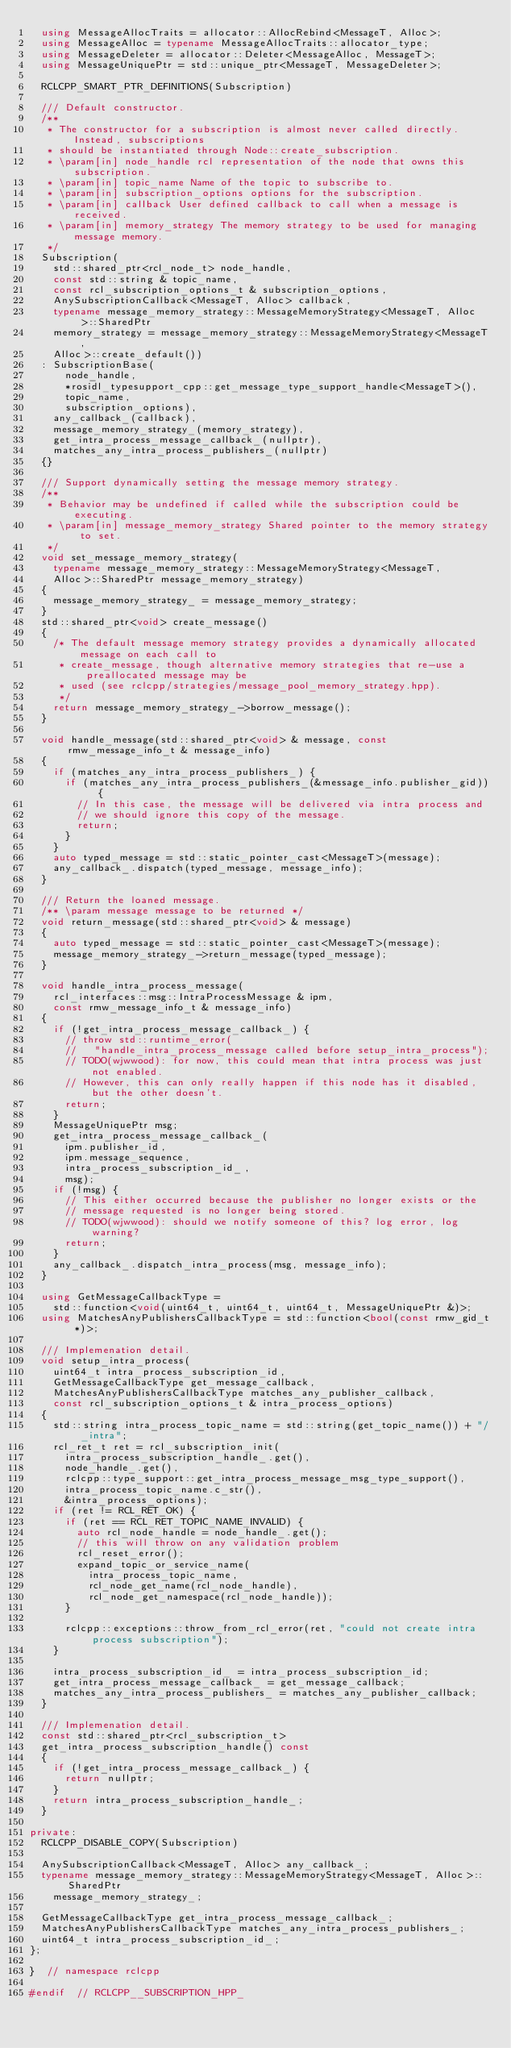<code> <loc_0><loc_0><loc_500><loc_500><_C++_>  using MessageAllocTraits = allocator::AllocRebind<MessageT, Alloc>;
  using MessageAlloc = typename MessageAllocTraits::allocator_type;
  using MessageDeleter = allocator::Deleter<MessageAlloc, MessageT>;
  using MessageUniquePtr = std::unique_ptr<MessageT, MessageDeleter>;

  RCLCPP_SMART_PTR_DEFINITIONS(Subscription)

  /// Default constructor.
  /**
   * The constructor for a subscription is almost never called directly. Instead, subscriptions
   * should be instantiated through Node::create_subscription.
   * \param[in] node_handle rcl representation of the node that owns this subscription.
   * \param[in] topic_name Name of the topic to subscribe to.
   * \param[in] subscription_options options for the subscription.
   * \param[in] callback User defined callback to call when a message is received.
   * \param[in] memory_strategy The memory strategy to be used for managing message memory.
   */
  Subscription(
    std::shared_ptr<rcl_node_t> node_handle,
    const std::string & topic_name,
    const rcl_subscription_options_t & subscription_options,
    AnySubscriptionCallback<MessageT, Alloc> callback,
    typename message_memory_strategy::MessageMemoryStrategy<MessageT, Alloc>::SharedPtr
    memory_strategy = message_memory_strategy::MessageMemoryStrategy<MessageT,
    Alloc>::create_default())
  : SubscriptionBase(
      node_handle,
      *rosidl_typesupport_cpp::get_message_type_support_handle<MessageT>(),
      topic_name,
      subscription_options),
    any_callback_(callback),
    message_memory_strategy_(memory_strategy),
    get_intra_process_message_callback_(nullptr),
    matches_any_intra_process_publishers_(nullptr)
  {}

  /// Support dynamically setting the message memory strategy.
  /**
   * Behavior may be undefined if called while the subscription could be executing.
   * \param[in] message_memory_strategy Shared pointer to the memory strategy to set.
   */
  void set_message_memory_strategy(
    typename message_memory_strategy::MessageMemoryStrategy<MessageT,
    Alloc>::SharedPtr message_memory_strategy)
  {
    message_memory_strategy_ = message_memory_strategy;
  }
  std::shared_ptr<void> create_message()
  {
    /* The default message memory strategy provides a dynamically allocated message on each call to
     * create_message, though alternative memory strategies that re-use a preallocated message may be
     * used (see rclcpp/strategies/message_pool_memory_strategy.hpp).
     */
    return message_memory_strategy_->borrow_message();
  }

  void handle_message(std::shared_ptr<void> & message, const rmw_message_info_t & message_info)
  {
    if (matches_any_intra_process_publishers_) {
      if (matches_any_intra_process_publishers_(&message_info.publisher_gid)) {
        // In this case, the message will be delivered via intra process and
        // we should ignore this copy of the message.
        return;
      }
    }
    auto typed_message = std::static_pointer_cast<MessageT>(message);
    any_callback_.dispatch(typed_message, message_info);
  }

  /// Return the loaned message.
  /** \param message message to be returned */
  void return_message(std::shared_ptr<void> & message)
  {
    auto typed_message = std::static_pointer_cast<MessageT>(message);
    message_memory_strategy_->return_message(typed_message);
  }

  void handle_intra_process_message(
    rcl_interfaces::msg::IntraProcessMessage & ipm,
    const rmw_message_info_t & message_info)
  {
    if (!get_intra_process_message_callback_) {
      // throw std::runtime_error(
      //   "handle_intra_process_message called before setup_intra_process");
      // TODO(wjwwood): for now, this could mean that intra process was just not enabled.
      // However, this can only really happen if this node has it disabled, but the other doesn't.
      return;
    }
    MessageUniquePtr msg;
    get_intra_process_message_callback_(
      ipm.publisher_id,
      ipm.message_sequence,
      intra_process_subscription_id_,
      msg);
    if (!msg) {
      // This either occurred because the publisher no longer exists or the
      // message requested is no longer being stored.
      // TODO(wjwwood): should we notify someone of this? log error, log warning?
      return;
    }
    any_callback_.dispatch_intra_process(msg, message_info);
  }

  using GetMessageCallbackType =
    std::function<void(uint64_t, uint64_t, uint64_t, MessageUniquePtr &)>;
  using MatchesAnyPublishersCallbackType = std::function<bool(const rmw_gid_t *)>;

  /// Implemenation detail.
  void setup_intra_process(
    uint64_t intra_process_subscription_id,
    GetMessageCallbackType get_message_callback,
    MatchesAnyPublishersCallbackType matches_any_publisher_callback,
    const rcl_subscription_options_t & intra_process_options)
  {
    std::string intra_process_topic_name = std::string(get_topic_name()) + "/_intra";
    rcl_ret_t ret = rcl_subscription_init(
      intra_process_subscription_handle_.get(),
      node_handle_.get(),
      rclcpp::type_support::get_intra_process_message_msg_type_support(),
      intra_process_topic_name.c_str(),
      &intra_process_options);
    if (ret != RCL_RET_OK) {
      if (ret == RCL_RET_TOPIC_NAME_INVALID) {
        auto rcl_node_handle = node_handle_.get();
        // this will throw on any validation problem
        rcl_reset_error();
        expand_topic_or_service_name(
          intra_process_topic_name,
          rcl_node_get_name(rcl_node_handle),
          rcl_node_get_namespace(rcl_node_handle));
      }

      rclcpp::exceptions::throw_from_rcl_error(ret, "could not create intra process subscription");
    }

    intra_process_subscription_id_ = intra_process_subscription_id;
    get_intra_process_message_callback_ = get_message_callback;
    matches_any_intra_process_publishers_ = matches_any_publisher_callback;
  }

  /// Implemenation detail.
  const std::shared_ptr<rcl_subscription_t>
  get_intra_process_subscription_handle() const
  {
    if (!get_intra_process_message_callback_) {
      return nullptr;
    }
    return intra_process_subscription_handle_;
  }

private:
  RCLCPP_DISABLE_COPY(Subscription)

  AnySubscriptionCallback<MessageT, Alloc> any_callback_;
  typename message_memory_strategy::MessageMemoryStrategy<MessageT, Alloc>::SharedPtr
    message_memory_strategy_;

  GetMessageCallbackType get_intra_process_message_callback_;
  MatchesAnyPublishersCallbackType matches_any_intra_process_publishers_;
  uint64_t intra_process_subscription_id_;
};

}  // namespace rclcpp

#endif  // RCLCPP__SUBSCRIPTION_HPP_
</code> 